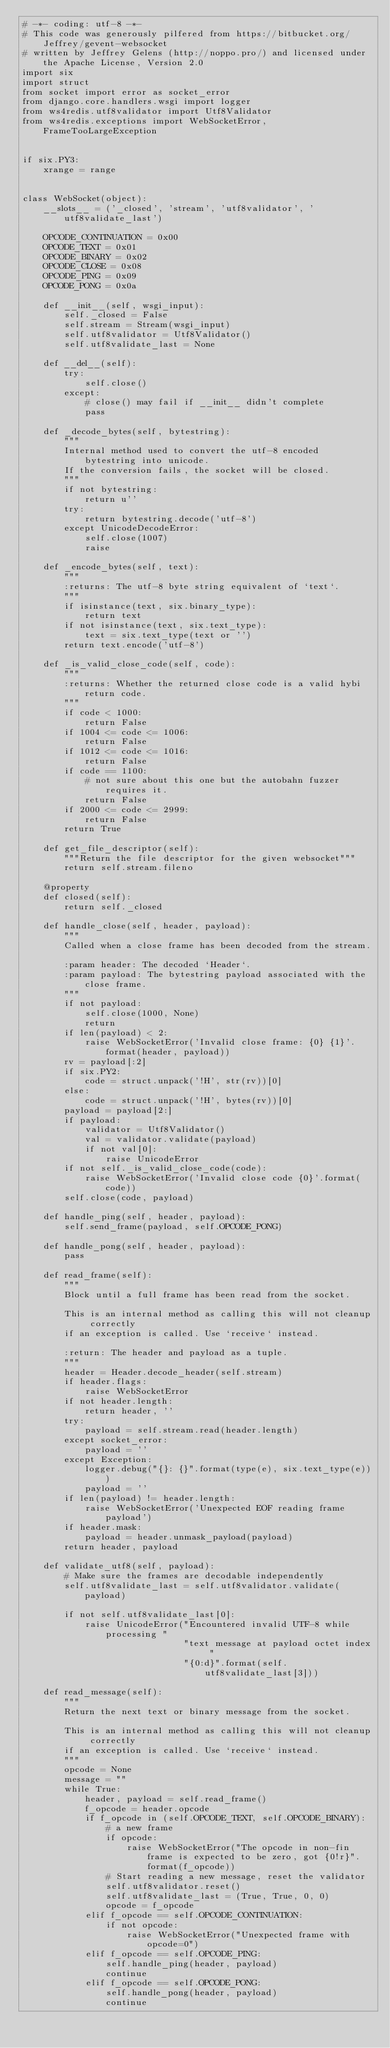<code> <loc_0><loc_0><loc_500><loc_500><_Python_># -*- coding: utf-8 -*-
# This code was generously pilfered from https://bitbucket.org/Jeffrey/gevent-websocket
# written by Jeffrey Gelens (http://noppo.pro/) and licensed under the Apache License, Version 2.0
import six
import struct
from socket import error as socket_error
from django.core.handlers.wsgi import logger
from ws4redis.utf8validator import Utf8Validator
from ws4redis.exceptions import WebSocketError, FrameTooLargeException


if six.PY3:
    xrange = range


class WebSocket(object):
    __slots__ = ('_closed', 'stream', 'utf8validator', 'utf8validate_last')

    OPCODE_CONTINUATION = 0x00
    OPCODE_TEXT = 0x01
    OPCODE_BINARY = 0x02
    OPCODE_CLOSE = 0x08
    OPCODE_PING = 0x09
    OPCODE_PONG = 0x0a

    def __init__(self, wsgi_input):
        self._closed = False
        self.stream = Stream(wsgi_input)
        self.utf8validator = Utf8Validator()
        self.utf8validate_last = None

    def __del__(self):
        try:
            self.close()
        except:
            # close() may fail if __init__ didn't complete
            pass

    def _decode_bytes(self, bytestring):
        """
        Internal method used to convert the utf-8 encoded bytestring into unicode.
        If the conversion fails, the socket will be closed.
        """
        if not bytestring:
            return u''
        try:
            return bytestring.decode('utf-8')
        except UnicodeDecodeError:
            self.close(1007)
            raise

    def _encode_bytes(self, text):
        """
        :returns: The utf-8 byte string equivalent of `text`.
        """
        if isinstance(text, six.binary_type):
            return text
        if not isinstance(text, six.text_type):
            text = six.text_type(text or '')
        return text.encode('utf-8')

    def _is_valid_close_code(self, code):
        """
        :returns: Whether the returned close code is a valid hybi return code.
        """
        if code < 1000:
            return False
        if 1004 <= code <= 1006:
            return False
        if 1012 <= code <= 1016:
            return False
        if code == 1100:
            # not sure about this one but the autobahn fuzzer requires it.
            return False
        if 2000 <= code <= 2999:
            return False
        return True

    def get_file_descriptor(self):
        """Return the file descriptor for the given websocket"""
        return self.stream.fileno

    @property
    def closed(self):
        return self._closed

    def handle_close(self, header, payload):
        """
        Called when a close frame has been decoded from the stream.

        :param header: The decoded `Header`.
        :param payload: The bytestring payload associated with the close frame.
        """
        if not payload:
            self.close(1000, None)
            return
        if len(payload) < 2:
            raise WebSocketError('Invalid close frame: {0} {1}'.format(header, payload))
        rv = payload[:2]
        if six.PY2:
            code = struct.unpack('!H', str(rv))[0]
        else:
            code = struct.unpack('!H', bytes(rv))[0]
        payload = payload[2:]
        if payload:
            validator = Utf8Validator()
            val = validator.validate(payload)
            if not val[0]:
                raise UnicodeError
        if not self._is_valid_close_code(code):
            raise WebSocketError('Invalid close code {0}'.format(code))
        self.close(code, payload)

    def handle_ping(self, header, payload):
        self.send_frame(payload, self.OPCODE_PONG)

    def handle_pong(self, header, payload):
        pass

    def read_frame(self):
        """
        Block until a full frame has been read from the socket.

        This is an internal method as calling this will not cleanup correctly
        if an exception is called. Use `receive` instead.

        :return: The header and payload as a tuple.
        """
        header = Header.decode_header(self.stream)
        if header.flags:
            raise WebSocketError
        if not header.length:
            return header, ''
        try:
            payload = self.stream.read(header.length)
        except socket_error:
            payload = ''
        except Exception:
            logger.debug("{}: {}".format(type(e), six.text_type(e)))
            payload = ''
        if len(payload) != header.length:
            raise WebSocketError('Unexpected EOF reading frame payload')
        if header.mask:
            payload = header.unmask_payload(payload)
        return header, payload

    def validate_utf8(self, payload):
        # Make sure the frames are decodable independently
        self.utf8validate_last = self.utf8validator.validate(payload)

        if not self.utf8validate_last[0]:
            raise UnicodeError("Encountered invalid UTF-8 while processing "
                               "text message at payload octet index "
                               "{0:d}".format(self.utf8validate_last[3]))

    def read_message(self):
        """
        Return the next text or binary message from the socket.

        This is an internal method as calling this will not cleanup correctly
        if an exception is called. Use `receive` instead.
        """
        opcode = None
        message = ""
        while True:
            header, payload = self.read_frame()
            f_opcode = header.opcode
            if f_opcode in (self.OPCODE_TEXT, self.OPCODE_BINARY):
                # a new frame
                if opcode:
                    raise WebSocketError("The opcode in non-fin frame is expected to be zero, got {0!r}".format(f_opcode))
                # Start reading a new message, reset the validator
                self.utf8validator.reset()
                self.utf8validate_last = (True, True, 0, 0)
                opcode = f_opcode
            elif f_opcode == self.OPCODE_CONTINUATION:
                if not opcode:
                    raise WebSocketError("Unexpected frame with opcode=0")
            elif f_opcode == self.OPCODE_PING:
                self.handle_ping(header, payload)
                continue
            elif f_opcode == self.OPCODE_PONG:
                self.handle_pong(header, payload)
                continue</code> 